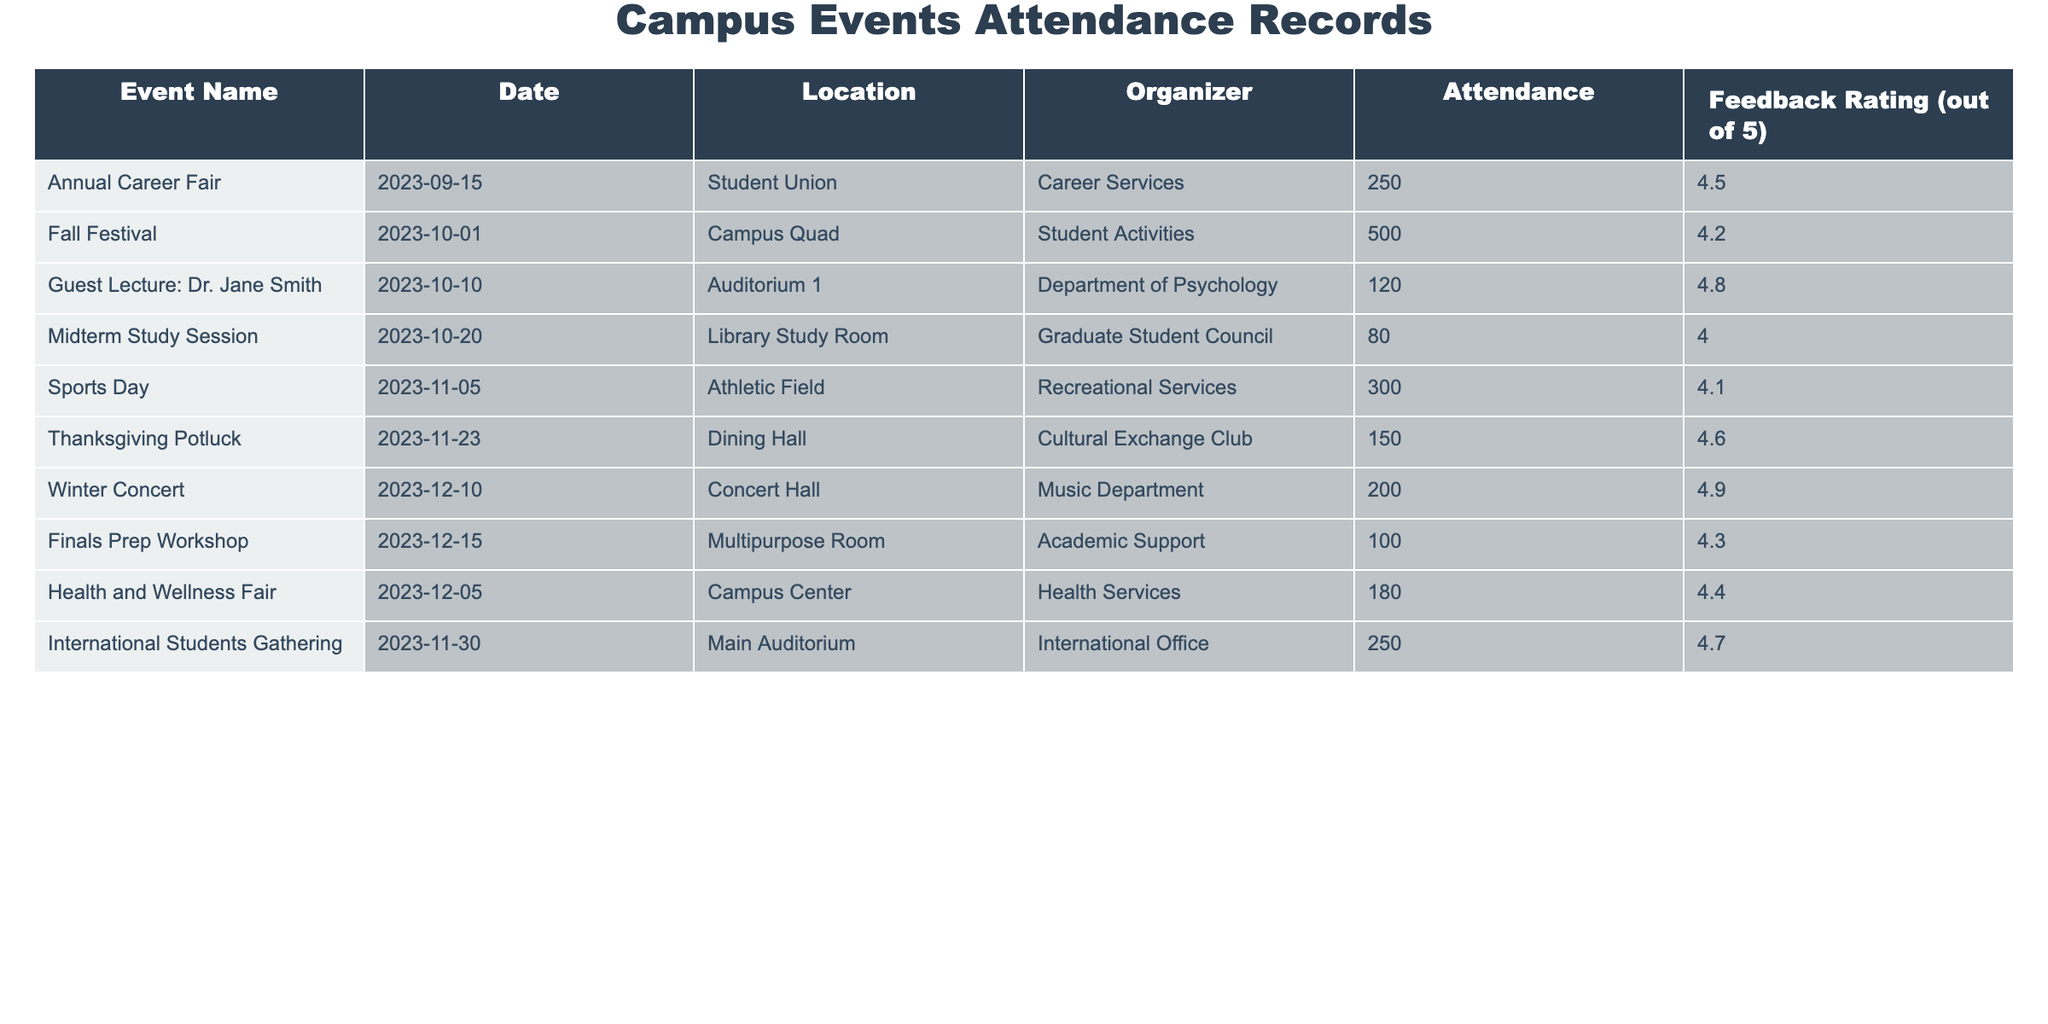What was the attendance at the Fall Festival? The table lists the attendance for the Fall Festival as 500.
Answer: 500 Who organized the Winter Concert? From the table, the organizer of the Winter Concert is the Music Department.
Answer: Music Department What is the average feedback rating of all events? To find the average, add up all the feedback ratings (4.5 + 4.2 + 4.8 + 4.0 + 4.1 + 4.6 + 4.9 + 4.3 + 4.4 + 4.7) which equals 44.5, and divide by the number of events (10). So, 44.5/10 = 4.45.
Answer: 4.45 Was there a midterm study session held in the Library? Yes, according to the table, the Midterm Study Session was held in the Library Study Room.
Answer: Yes Which event had the highest attendance? By reviewing the attendance figures, the Fall Festival has the highest attendance at 500 compared to the other events.
Answer: Fall Festival How many events were organized by Student Activities? The table shows that there was one event organized by Student Activities, which is the Fall Festival.
Answer: 1 What was the feedback rating for the Final Prep Workshop? The feedback rating for the Finals Prep Workshop is listed in the table as 4.3.
Answer: 4.3 What is the difference in attendance between the Annual Career Fair and the Thanksgiving Potluck? The attendance for the Annual Career Fair is 250, and for the Thanksgiving Potluck, it is 150. The difference is calculated as 250 - 150 = 100.
Answer: 100 Which event had the lowest attendance? The table indicates that the Midterm Study Session had the lowest attendance, with 80 participants.
Answer: Midterm Study Session How many events had a feedback rating of 4.6 or higher? The events with feedback ratings of 4.6 or higher are the Annual Career Fair, Guest Lecture: Dr. Jane Smith, Thanksgiving Potluck, Winter Concert, and International Students Gathering. That's a total of 5 events.
Answer: 5 